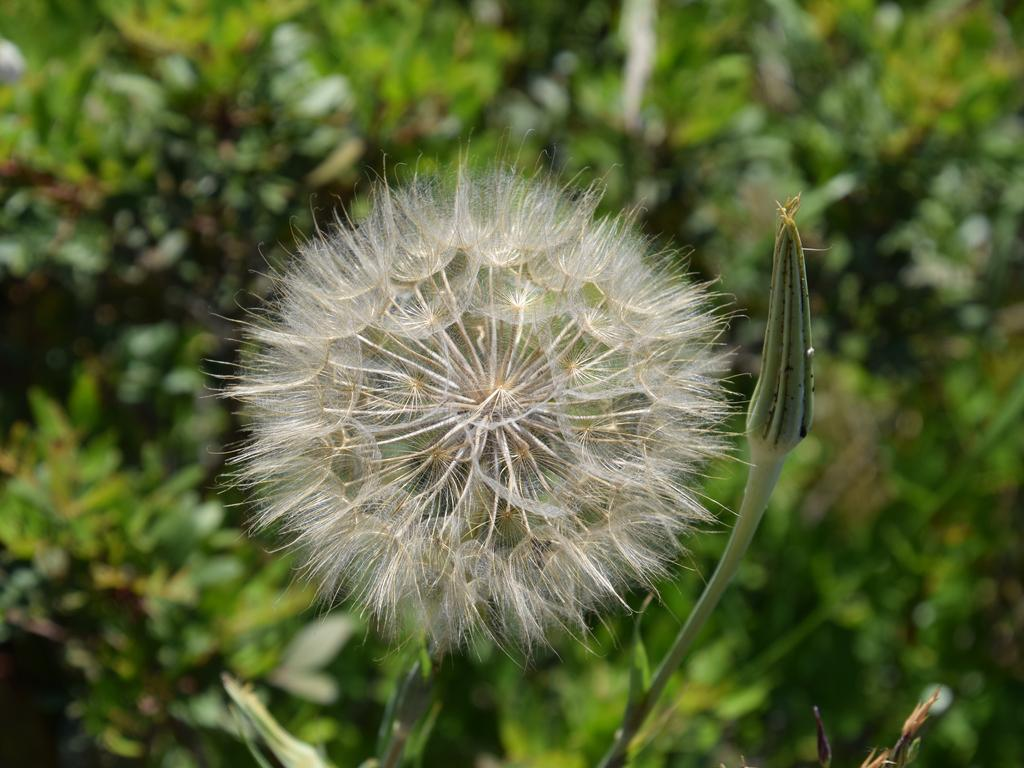What is the main subject in the center of the image? There is a flower in the center of the image, and there is also a bud. What can be seen in the background of the image? There are trees in the background of the image. What type of game is being played in the image? A: There is no game present in the image; it features a flower, a bud, and trees in the background. What ideas are being discussed in the image? There is no discussion or ideas present in the image; it is a still image of a flower, a bud, and trees. 